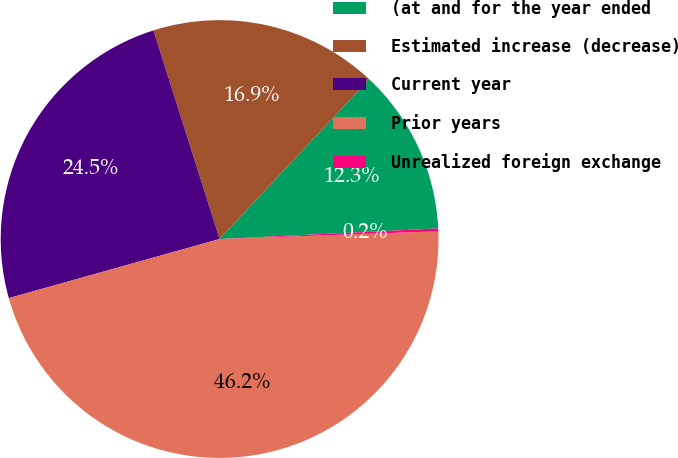<chart> <loc_0><loc_0><loc_500><loc_500><pie_chart><fcel>(at and for the year ended<fcel>Estimated increase (decrease)<fcel>Current year<fcel>Prior years<fcel>Unrealized foreign exchange<nl><fcel>12.26%<fcel>16.86%<fcel>24.46%<fcel>46.21%<fcel>0.21%<nl></chart> 